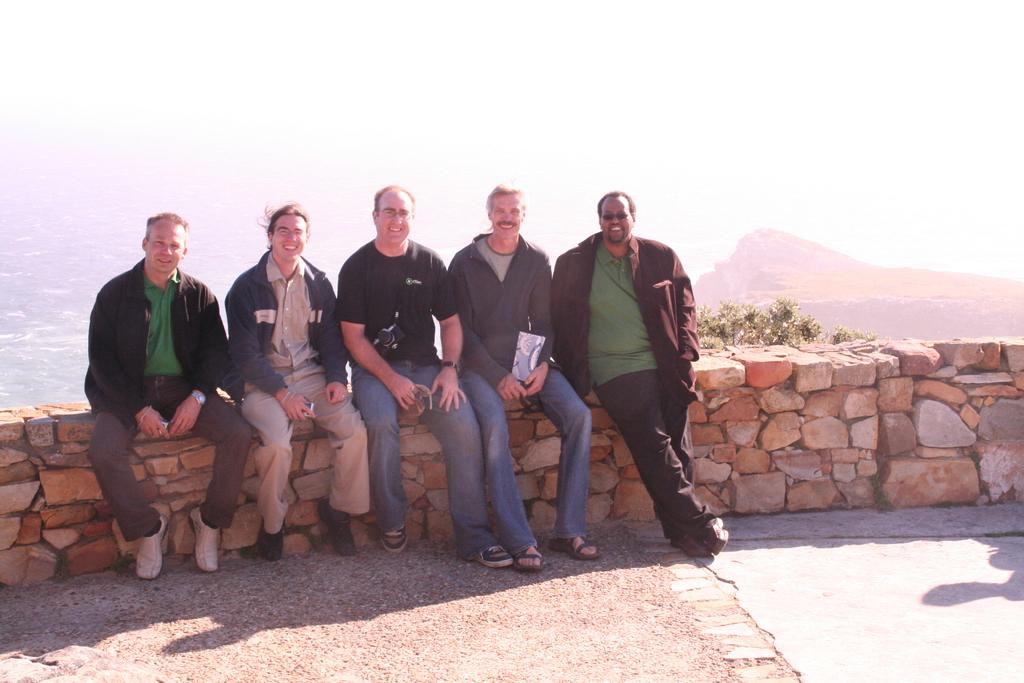How many people are in the image? There is a group of persons in the image. What are the people wearing? The persons are wearing different color dresses. What expression do the people have? The persons are smiling. Where are the people sitting? The persons are sitting on a stone wall. What is near the stone wall? There is a floor near the stone wall. What can be seen in the background of the image? There are trees, mountains, and the sky visible in the background of the image. Can you see a pig playing with a doll in the image? There is no pig or doll present in the image. 